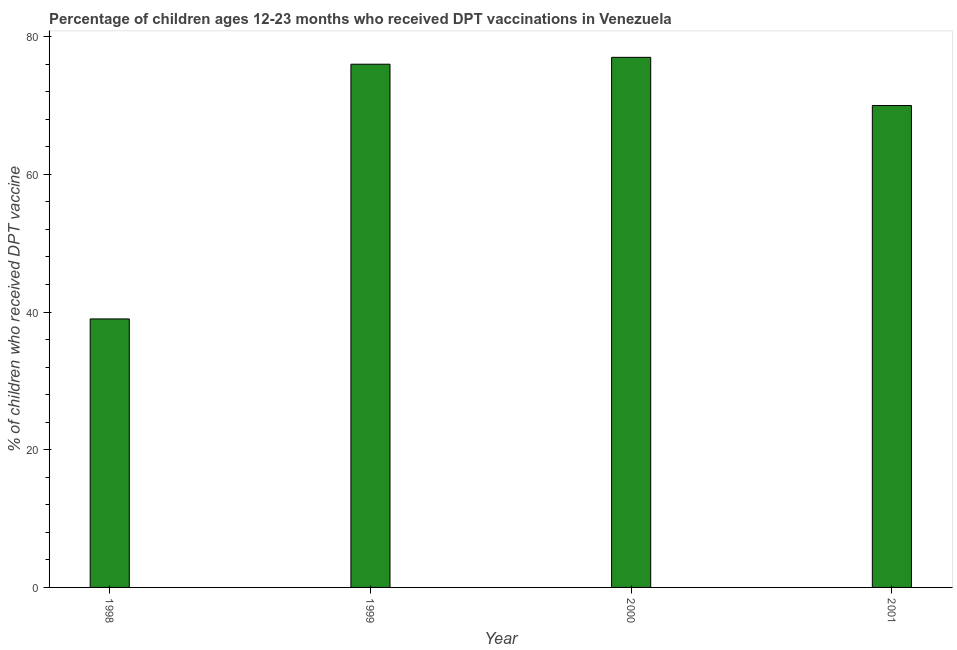What is the title of the graph?
Provide a succinct answer. Percentage of children ages 12-23 months who received DPT vaccinations in Venezuela. What is the label or title of the Y-axis?
Ensure brevity in your answer.  % of children who received DPT vaccine. Across all years, what is the minimum percentage of children who received dpt vaccine?
Offer a terse response. 39. In which year was the percentage of children who received dpt vaccine maximum?
Offer a terse response. 2000. In which year was the percentage of children who received dpt vaccine minimum?
Your response must be concise. 1998. What is the sum of the percentage of children who received dpt vaccine?
Offer a very short reply. 262. In how many years, is the percentage of children who received dpt vaccine greater than 8 %?
Offer a terse response. 4. What is the ratio of the percentage of children who received dpt vaccine in 1998 to that in 1999?
Give a very brief answer. 0.51. What is the difference between the highest and the second highest percentage of children who received dpt vaccine?
Provide a short and direct response. 1. Is the sum of the percentage of children who received dpt vaccine in 1999 and 2000 greater than the maximum percentage of children who received dpt vaccine across all years?
Give a very brief answer. Yes. In how many years, is the percentage of children who received dpt vaccine greater than the average percentage of children who received dpt vaccine taken over all years?
Offer a terse response. 3. How many years are there in the graph?
Keep it short and to the point. 4. What is the difference between two consecutive major ticks on the Y-axis?
Offer a very short reply. 20. Are the values on the major ticks of Y-axis written in scientific E-notation?
Ensure brevity in your answer.  No. What is the % of children who received DPT vaccine in 2000?
Provide a short and direct response. 77. What is the difference between the % of children who received DPT vaccine in 1998 and 1999?
Your response must be concise. -37. What is the difference between the % of children who received DPT vaccine in 1998 and 2000?
Give a very brief answer. -38. What is the difference between the % of children who received DPT vaccine in 1998 and 2001?
Ensure brevity in your answer.  -31. What is the difference between the % of children who received DPT vaccine in 1999 and 2000?
Offer a very short reply. -1. What is the difference between the % of children who received DPT vaccine in 1999 and 2001?
Your response must be concise. 6. What is the ratio of the % of children who received DPT vaccine in 1998 to that in 1999?
Offer a very short reply. 0.51. What is the ratio of the % of children who received DPT vaccine in 1998 to that in 2000?
Give a very brief answer. 0.51. What is the ratio of the % of children who received DPT vaccine in 1998 to that in 2001?
Offer a very short reply. 0.56. What is the ratio of the % of children who received DPT vaccine in 1999 to that in 2001?
Provide a short and direct response. 1.09. 